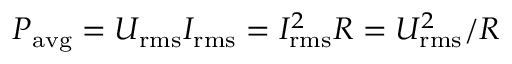<formula> <loc_0><loc_0><loc_500><loc_500>P _ { a v g } = U _ { r m s } I _ { r m s } = I _ { r m s } ^ { 2 } R = U _ { r m s } ^ { 2 } / R</formula> 